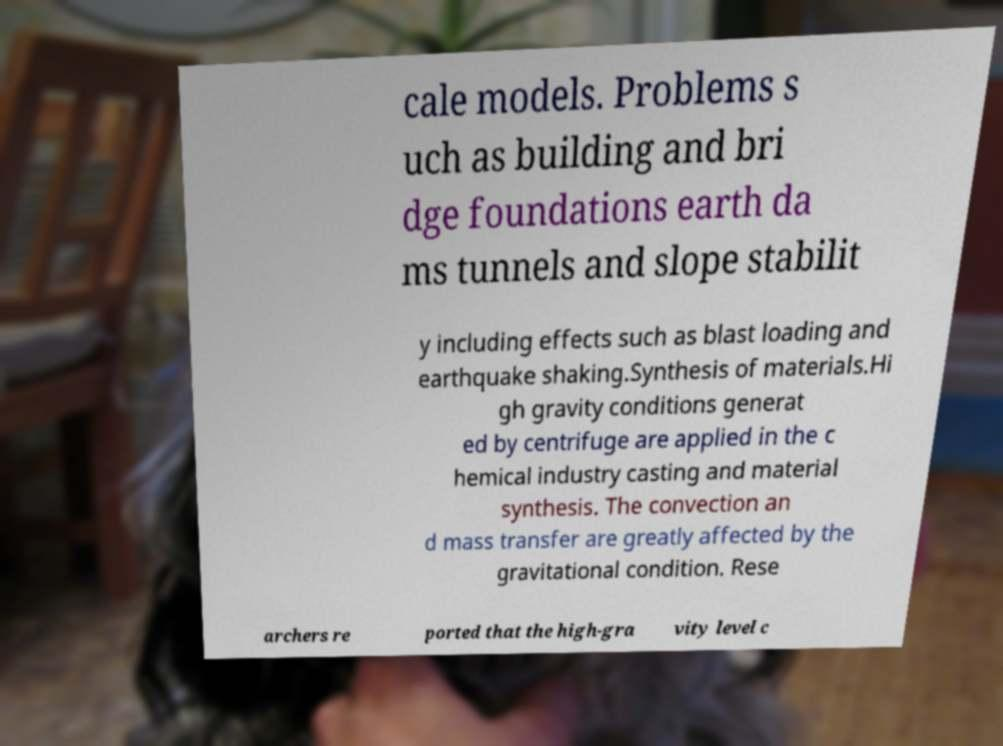There's text embedded in this image that I need extracted. Can you transcribe it verbatim? cale models. Problems s uch as building and bri dge foundations earth da ms tunnels and slope stabilit y including effects such as blast loading and earthquake shaking.Synthesis of materials.Hi gh gravity conditions generat ed by centrifuge are applied in the c hemical industry casting and material synthesis. The convection an d mass transfer are greatly affected by the gravitational condition. Rese archers re ported that the high-gra vity level c 